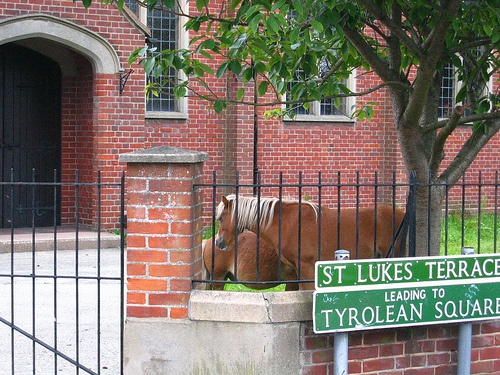Describe the objects in this image and their specific colors. I can see horse in brown, maroon, and gray tones and horse in brown, maroon, and black tones in this image. 